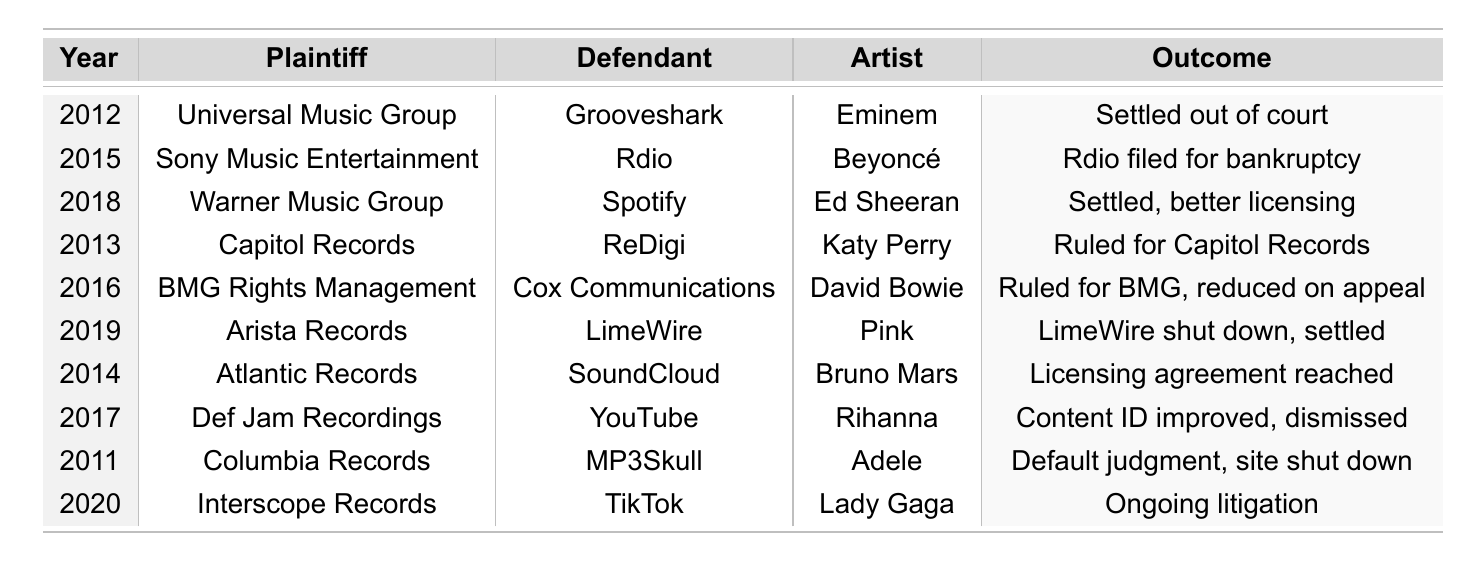What year did the case involving Eminem occur? The table lists the year of the case for Eminem as 2012.
Answer: 2012 Which plaintiff sued YouTube for copyright infringement? According to the table, the plaintiff against YouTube was Def Jam Recordings.
Answer: Def Jam Recordings What was the outcome of the case involving Katy Perry? The table records that the outcome for Katy Perry's case was ruled in favor of Capitol Records.
Answer: Ruled in favor of Capitol Records How much damages did BMG Rights Management seek in their case? Looking at the table, BMG Rights Management sought damages of 33 million.
Answer: 33000000 Did any cases settle out of court? The table indicates that Eminem's case was settled out of court, so yes, there were cases that settled out of court.
Answer: Yes What song was involved in the case against LimeWire? The table shows that the song involved in the case against LimeWire was "Just Like a Pill" by Pink.
Answer: Just Like a Pill How many cases were settled as a result of ongoing litigation? The table shows one ongoing litigation case involving Lady Gaga which is not settled, so the count is zero.
Answer: 0 Which legal firm represented Warner Music Group? From the table, Warner Music Group was represented by Pryor Cashman LLP.
Answer: Pryor Cashman LLP What is the total amount of damages sought in cases from 2016? Reviewing the table, the total damages sought in 2016 adds up to 33 million, corresponding to the case against Cox Communications.
Answer: 33000000 Identify the defendant in the case involving Rihanna. The table lists YouTube as the defendant in the case involving Rihanna.
Answer: YouTube How many cases were filed in total? Counting the entries in the table reveals there are ten cases listed.
Answer: 10 Which year had the most recent copyright infringement case? The most recent case listed in the table is from the year 2020.
Answer: 2020 What is the average amount of damages sought across all cases? The total damages sought across all cases (15M + 8M + 25M + 5M + 33M + 75M + 10M + 20M + 12M + 30M = 238M) divided by 10 cases equals 23.8M.
Answer: 23800000 Was there a case in which the plaintiff filed for bankruptcy? Yes, according to the table, Rdio filed for bankruptcy in their case against Sony Music Entertainment.
Answer: Yes Who was the artist affected by the case against TikTok? The table shows that Lady Gaga was the artist affected in the case against TikTok.
Answer: Lady Gaga 